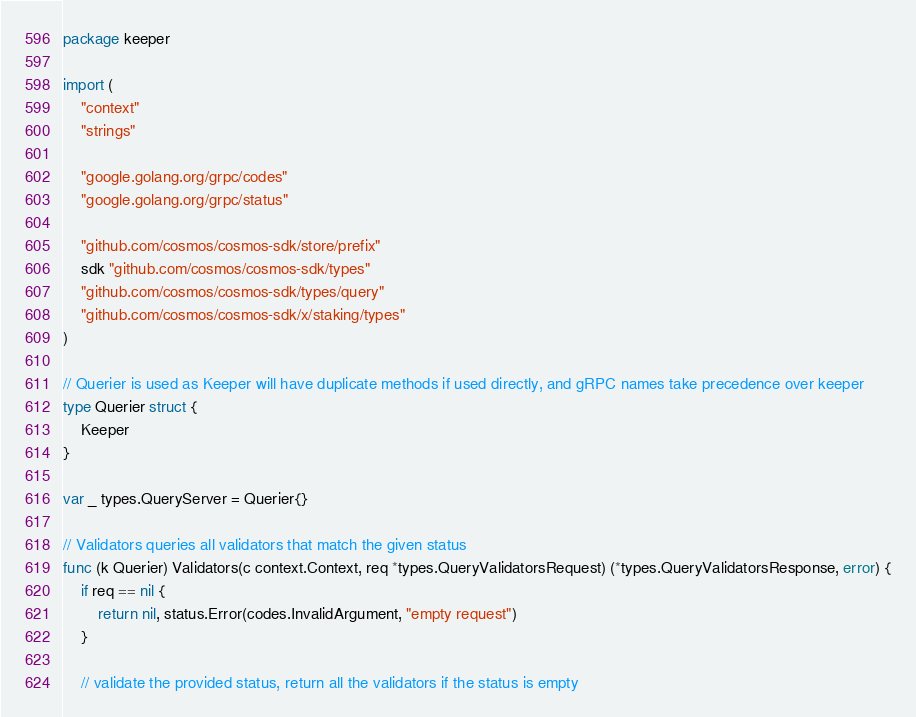Convert code to text. <code><loc_0><loc_0><loc_500><loc_500><_Go_>package keeper

import (
	"context"
	"strings"

	"google.golang.org/grpc/codes"
	"google.golang.org/grpc/status"

	"github.com/cosmos/cosmos-sdk/store/prefix"
	sdk "github.com/cosmos/cosmos-sdk/types"
	"github.com/cosmos/cosmos-sdk/types/query"
	"github.com/cosmos/cosmos-sdk/x/staking/types"
)

// Querier is used as Keeper will have duplicate methods if used directly, and gRPC names take precedence over keeper
type Querier struct {
	Keeper
}

var _ types.QueryServer = Querier{}

// Validators queries all validators that match the given status
func (k Querier) Validators(c context.Context, req *types.QueryValidatorsRequest) (*types.QueryValidatorsResponse, error) {
	if req == nil {
		return nil, status.Error(codes.InvalidArgument, "empty request")
	}

	// validate the provided status, return all the validators if the status is empty</code> 